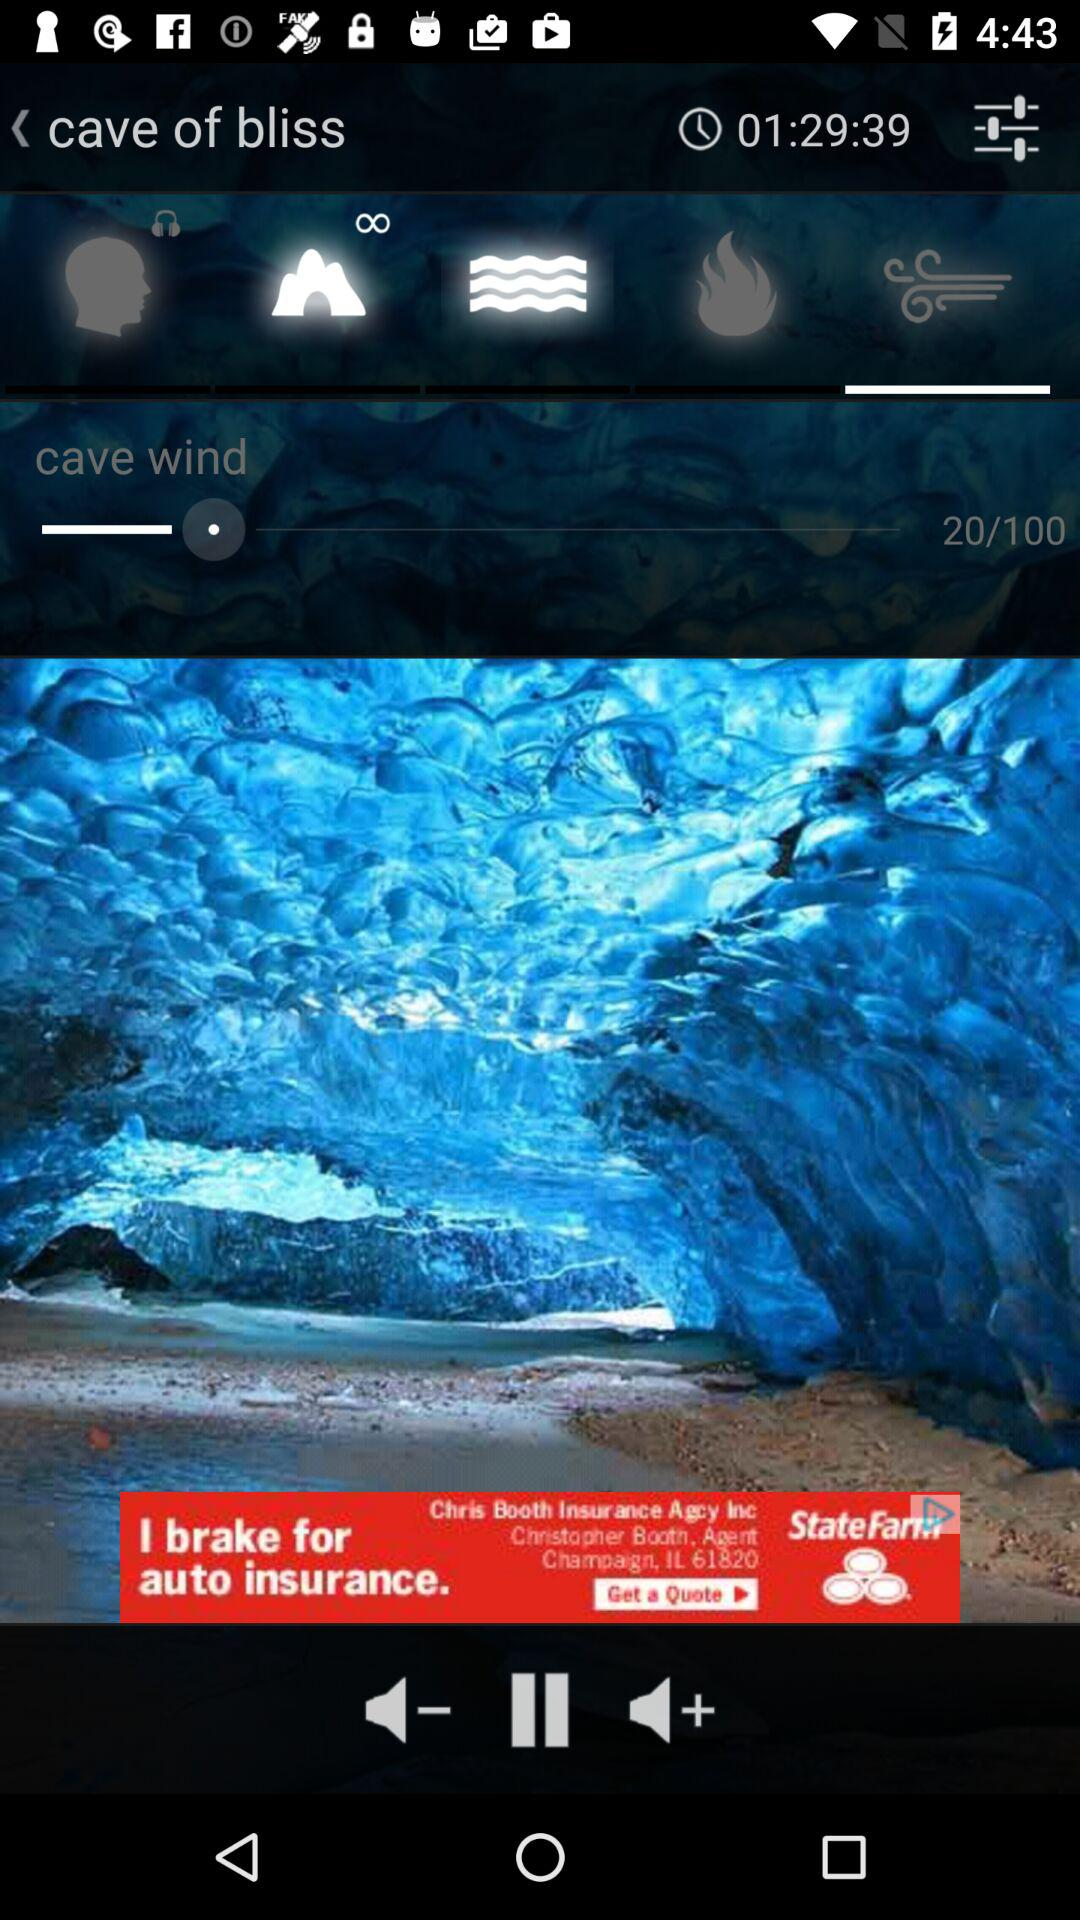What is the maximum limit for selecting cave wind? The maximum limit for selecting cave wind is 100. 